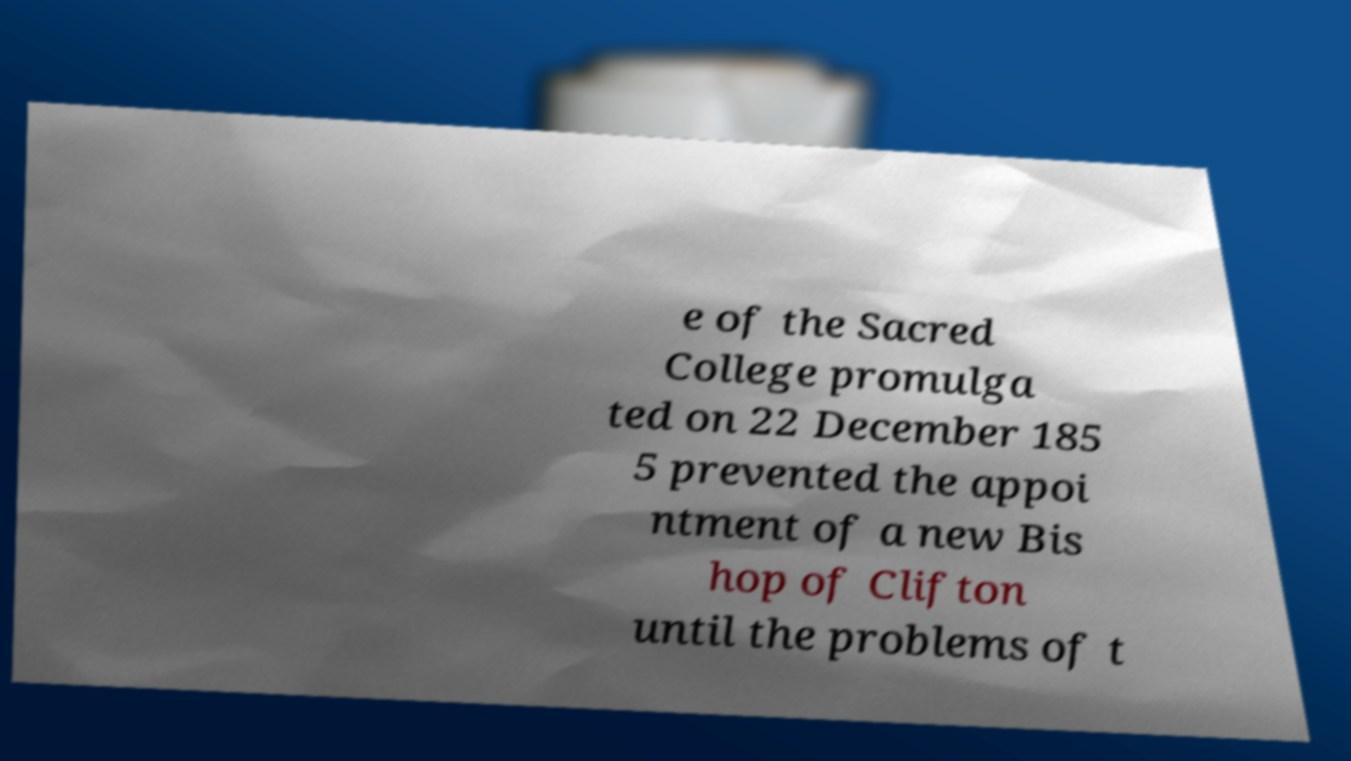For documentation purposes, I need the text within this image transcribed. Could you provide that? e of the Sacred College promulga ted on 22 December 185 5 prevented the appoi ntment of a new Bis hop of Clifton until the problems of t 